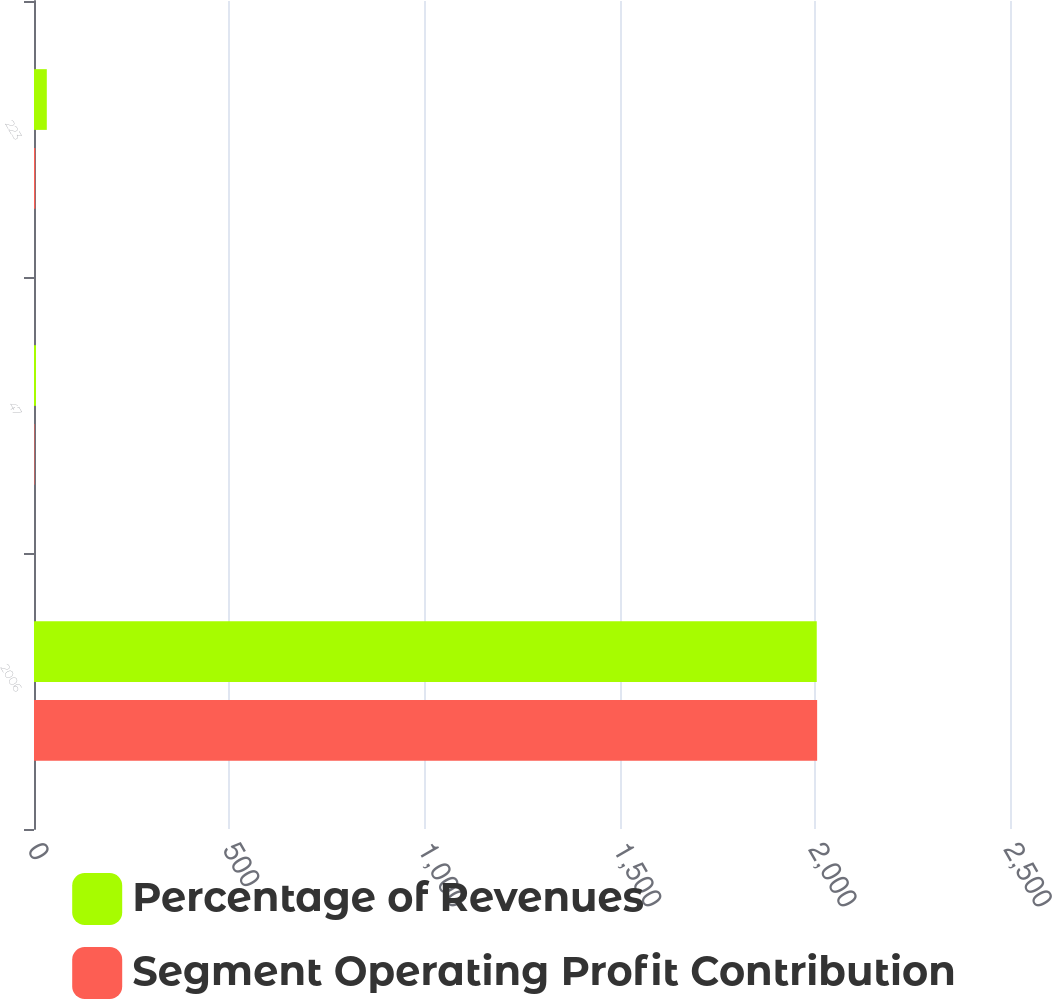Convert chart to OTSL. <chart><loc_0><loc_0><loc_500><loc_500><stacked_bar_chart><ecel><fcel>2006<fcel>47<fcel>223<nl><fcel>Percentage of Revenues<fcel>2005<fcel>5.2<fcel>32.8<nl><fcel>Segment Operating Profit Contribution<fcel>2006<fcel>1.3<fcel>3.3<nl></chart> 